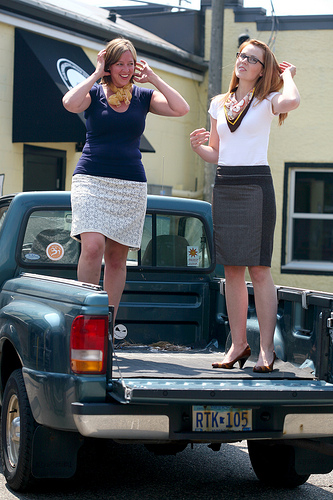<image>
Can you confirm if the woman is on the rug? Yes. Looking at the image, I can see the woman is positioned on top of the rug, with the rug providing support. Is the woman behind the truck? No. The woman is not behind the truck. From this viewpoint, the woman appears to be positioned elsewhere in the scene. Where is the person in relation to the car? Is it in front of the car? No. The person is not in front of the car. The spatial positioning shows a different relationship between these objects. 